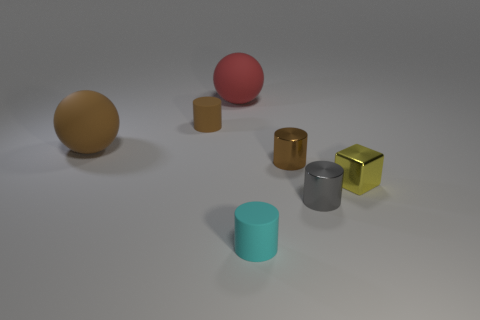Add 3 cyan cylinders. How many objects exist? 10 Subtract all blocks. How many objects are left? 6 Subtract all large gray rubber cylinders. Subtract all small gray things. How many objects are left? 6 Add 2 large things. How many large things are left? 4 Add 3 tiny metal objects. How many tiny metal objects exist? 6 Subtract 1 cyan cylinders. How many objects are left? 6 